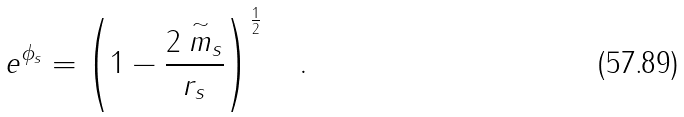<formula> <loc_0><loc_0><loc_500><loc_500>e ^ { \phi _ { s } } = \left ( 1 - \frac { 2 \stackrel { \sim } { m } _ { s } } { r _ { s } } \right ) ^ { \frac { 1 } { 2 } } \quad .</formula> 